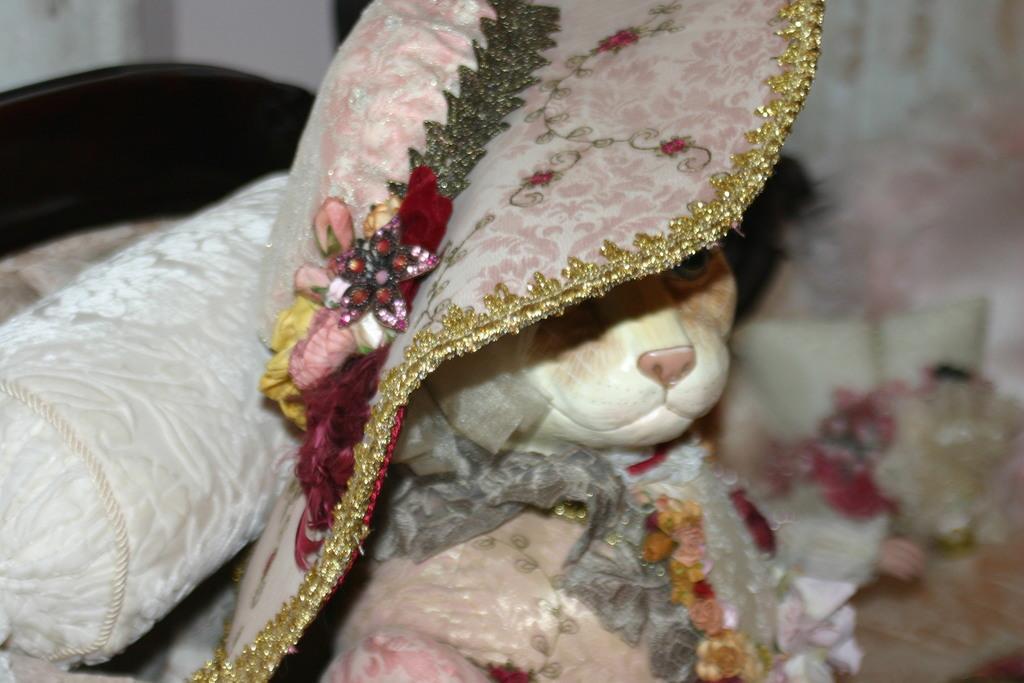Please provide a concise description of this image. In this image in the center there is one cat and the cat is wearing some hat, on the left side there is one pillow and in the background there are some objects. 